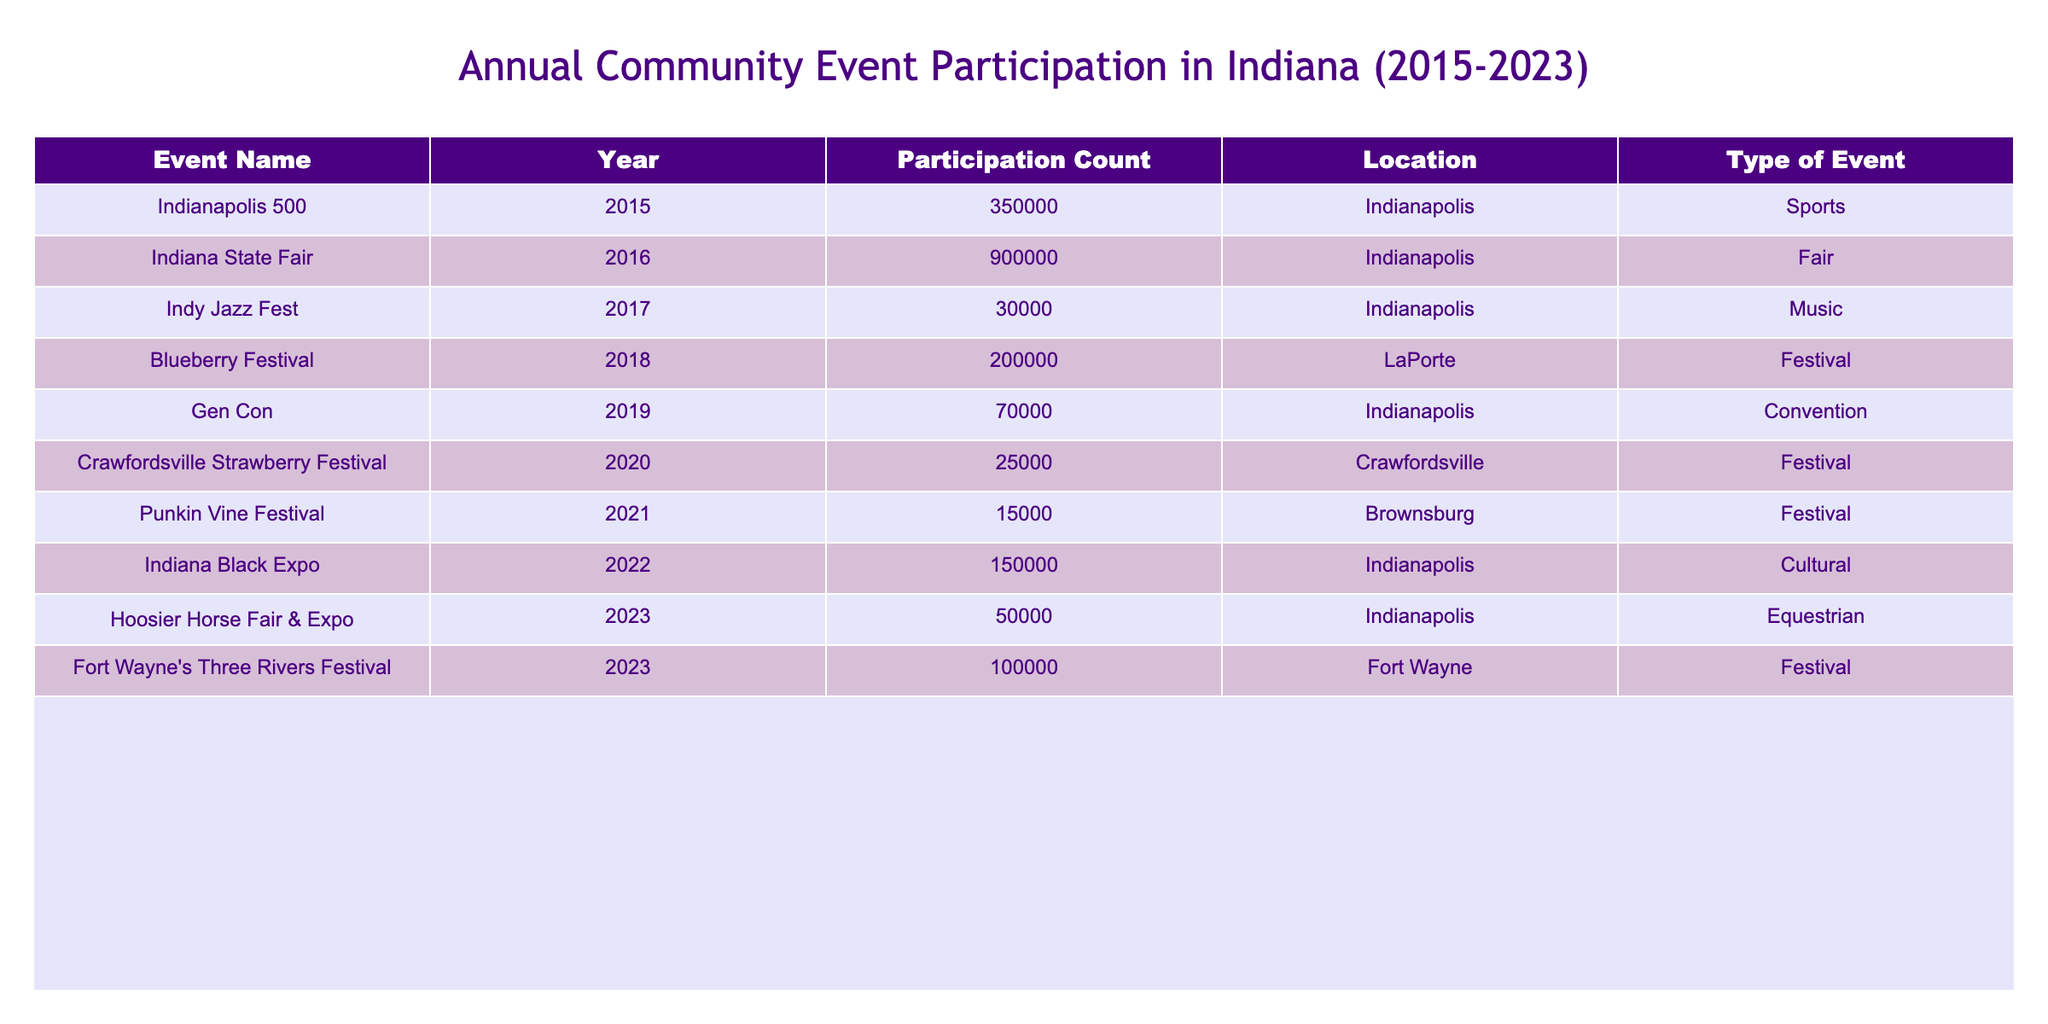What was the highest participation count from 2015 to 2023? The table shows various events and their participation counts, with the highest being 900,000 at the Indiana State Fair in 2016.
Answer: 900,000 Which year had the lowest participation in an event? The least participation recorded in the table is 15,000 for the Punkin Vine Festival in 2021.
Answer: 15,000 How many events had participation counts over 100,000? By reviewing the participation counts, the events with over 100,000 attendees are the Indiana State Fair (900,000), Indiana Black Expo (150,000), and Fort Wayne's Three Rivers Festival (100,000). Thus, there are three events.
Answer: 3 What was the total participation count for events in 2023? For 2023, the participation counts are 50,000 for the Hoosier Horse Fair & Expo and 100,000 for Fort Wayne's Three Rivers Festival. Adding these together: 50,000 + 100,000 = 150,000.
Answer: 150,000 Is there an event that occurred every year from 2015 to 2023? The table lists events for each year, none of which are repeated annually, so there is no single event that happens every year.
Answer: No What was the average participation count across all listed events? To find the average, we first sum the participation counts (350,000 + 900,000 + 30,000 + 200,000 + 70,000 + 25,000 + 15,000 + 150,000 + 50,000 + 100,000 = 1,890,000) and divide by the number of events (10), giving an average of 189,000.
Answer: 189,000 Which event type had the highest total attendance? Assessing the types of events and their respective counts: Sports (350,000), Fair (900,000 + 100,000), Music (30,000), Festival (200,000 + 25,000 + 15,000), Convention (70,000), Cultural (150,000), and Equestrian (50,000). The Fair type has the highest total (1,000,000).
Answer: Fair How many events took place in Indianapolis? The events held in Indianapolis are the Indianapolis 500, Indiana State Fair, Indy Jazz Fest, Gen Con, and Indiana Black Expo, making a total of five events.
Answer: 5 What was the difference in participation counts between the highest and lowest events? The participation for the Indiana State Fair (900,000) minus the Punkin Vine Festival (15,000) equals 885,000.
Answer: 885,000 What is the total attendance for music-related events? The only music-related event listed is the Indy Jazz Fest with 30,000 participants, leading to a total of 30,000.
Answer: 30,000 Did any event see an increase in participation from 2015 to 2023? By comparing the counts, only the Indiana State Fair in 2016 is significantly larger than others, and no event occurs in both years for direct comparison, thus no increases are identified.
Answer: No 